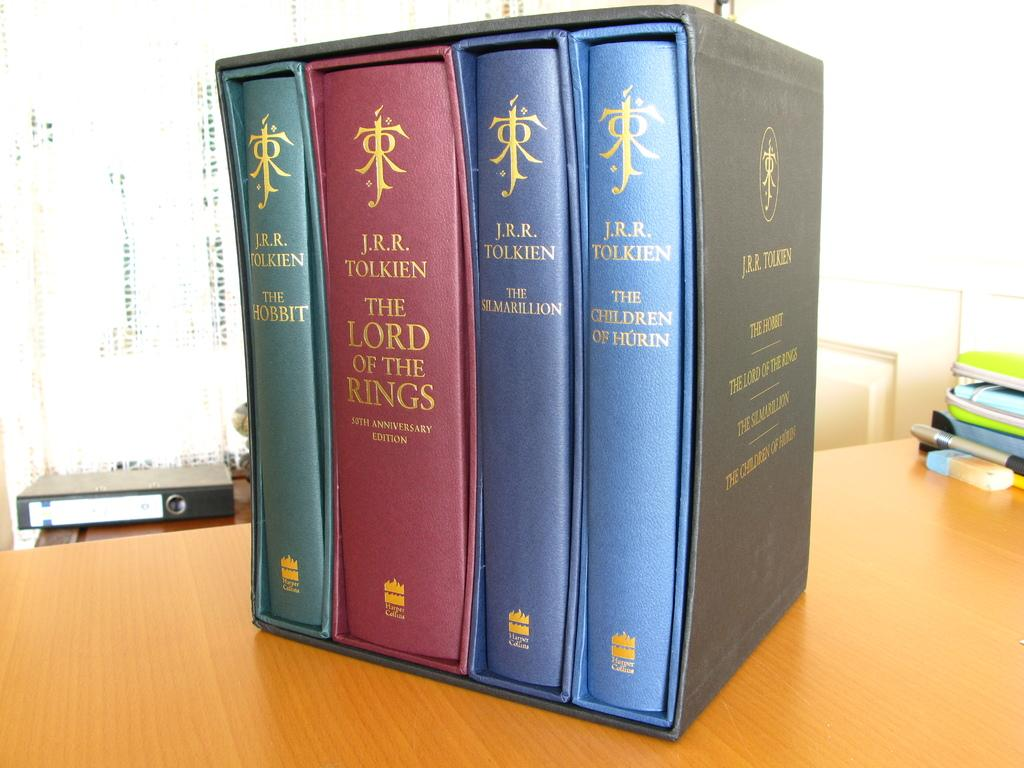<image>
Relay a brief, clear account of the picture shown. A collection of books by J.R.R. Tolkien are in a box set together. 